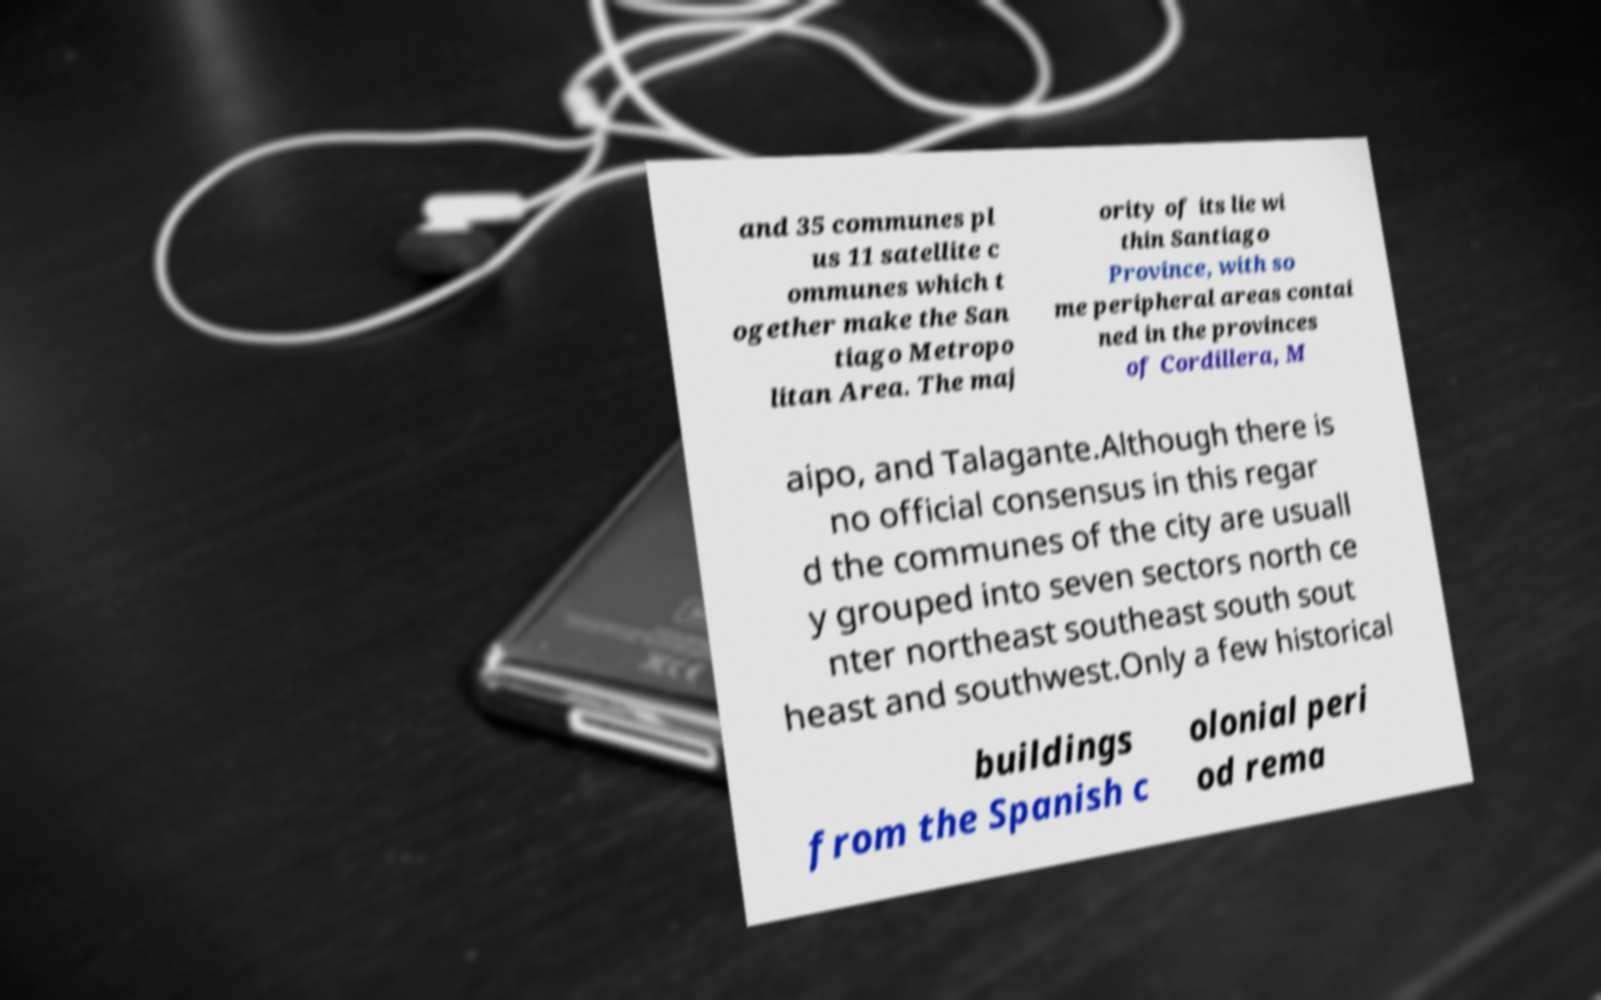Please identify and transcribe the text found in this image. and 35 communes pl us 11 satellite c ommunes which t ogether make the San tiago Metropo litan Area. The maj ority of its lie wi thin Santiago Province, with so me peripheral areas contai ned in the provinces of Cordillera, M aipo, and Talagante.Although there is no official consensus in this regar d the communes of the city are usuall y grouped into seven sectors north ce nter northeast southeast south sout heast and southwest.Only a few historical buildings from the Spanish c olonial peri od rema 